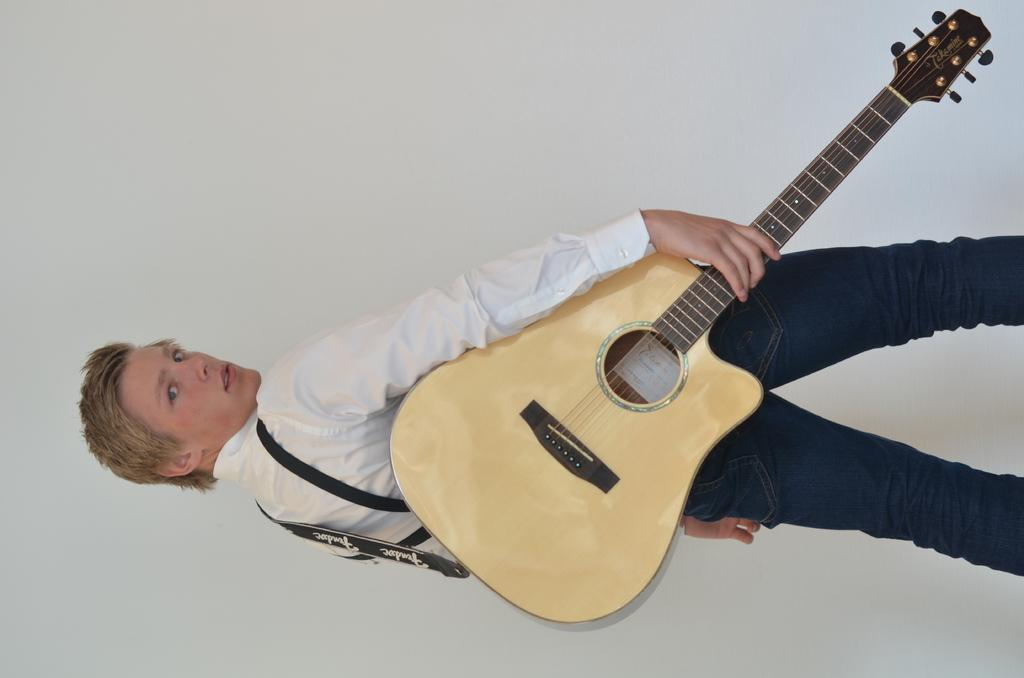What is the main subject of the image? There is a person in the image. What is the person doing in the image? The person is standing and holding a guitar. What can be seen in the background of the image? There is a wall in the background of the image. How many tents are visible in the image? There are no tents present in the image. What type of fuel is the person using to play the guitar in the image? The person is not using any fuel to play the guitar in the image; they are simply holding it. 